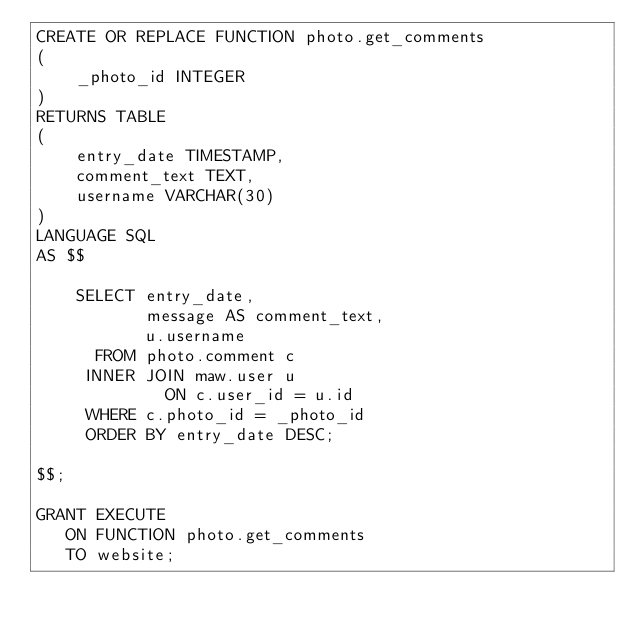<code> <loc_0><loc_0><loc_500><loc_500><_SQL_>CREATE OR REPLACE FUNCTION photo.get_comments
(
    _photo_id INTEGER
)
RETURNS TABLE
(
    entry_date TIMESTAMP,
    comment_text TEXT,
    username VARCHAR(30)
)
LANGUAGE SQL
AS $$

    SELECT entry_date,
           message AS comment_text,
           u.username
      FROM photo.comment c
     INNER JOIN maw.user u
             ON c.user_id = u.id
     WHERE c.photo_id = _photo_id
     ORDER BY entry_date DESC;

$$;

GRANT EXECUTE
   ON FUNCTION photo.get_comments
   TO website;
</code> 